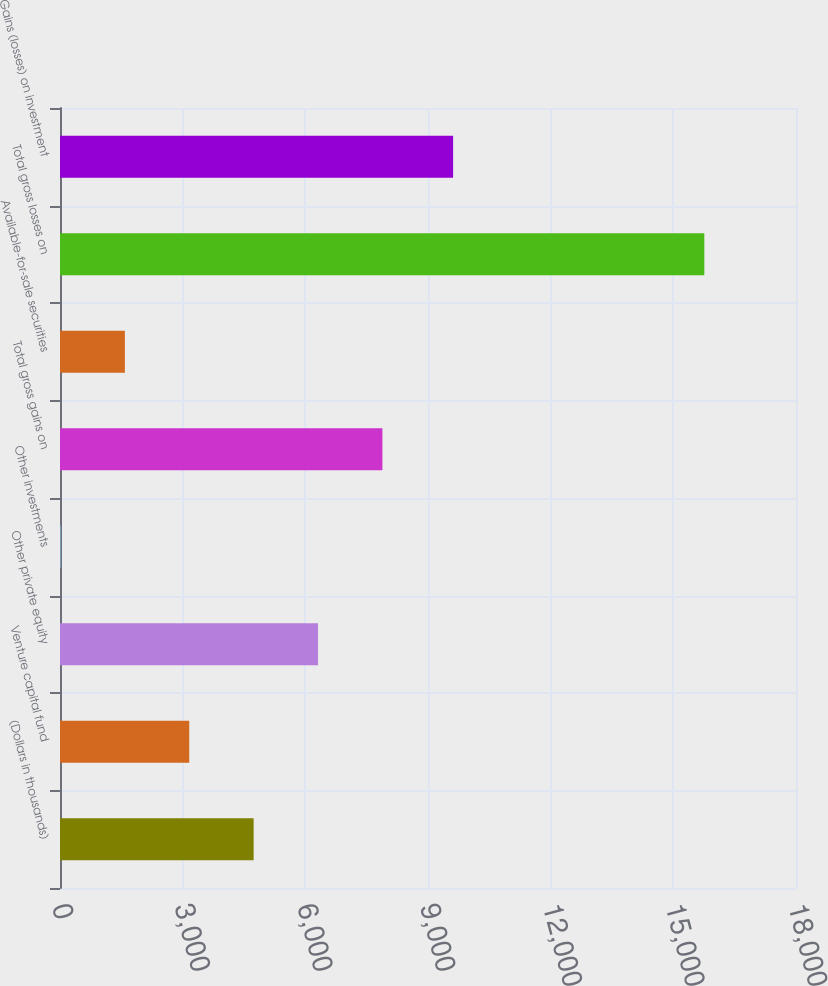Convert chart to OTSL. <chart><loc_0><loc_0><loc_500><loc_500><bar_chart><fcel>(Dollars in thousands)<fcel>Venture capital fund<fcel>Other private equity<fcel>Other investments<fcel>Total gross gains on<fcel>Available-for-sale securities<fcel>Total gross losses on<fcel>Gains (losses) on investment<nl><fcel>4735.8<fcel>3161.2<fcel>6310.4<fcel>12<fcel>7885<fcel>1586.6<fcel>15758<fcel>9614<nl></chart> 